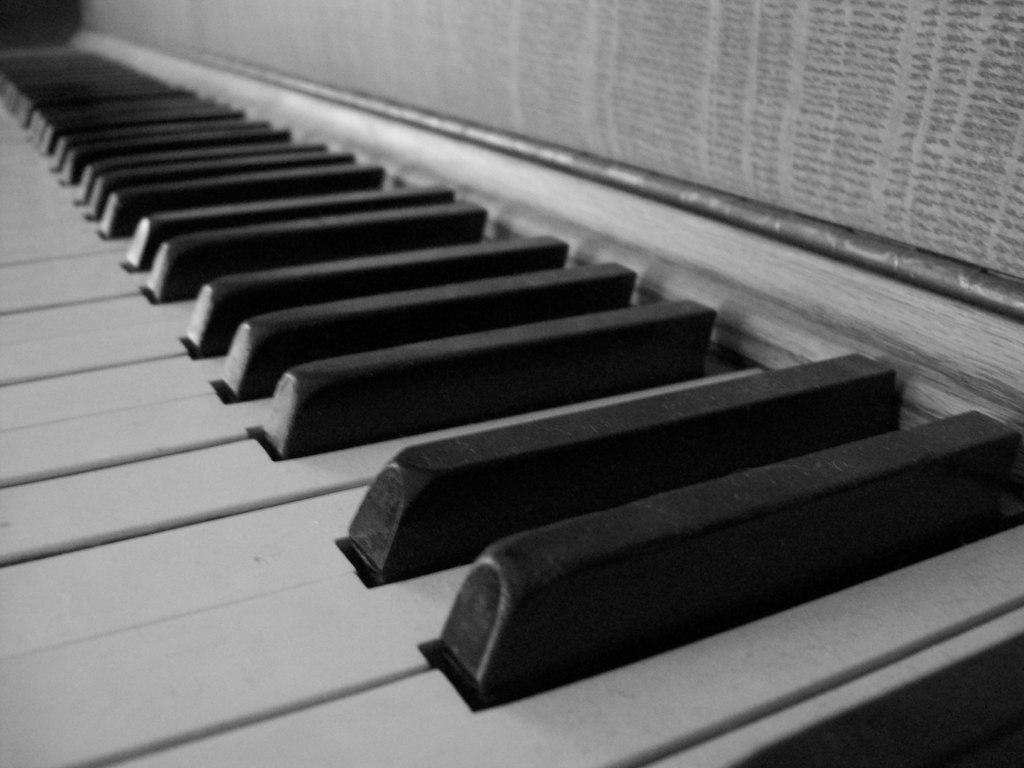What type of musical instrument is in the image? There is a musical instrument in the image. What can be observed about the keys of the musical instrument? The musical instrument has white and black keys. What type of fowl can be seen performing an operation on the musical instrument in the image? There is no fowl present in the image, and the musical instrument is not being operated on. 